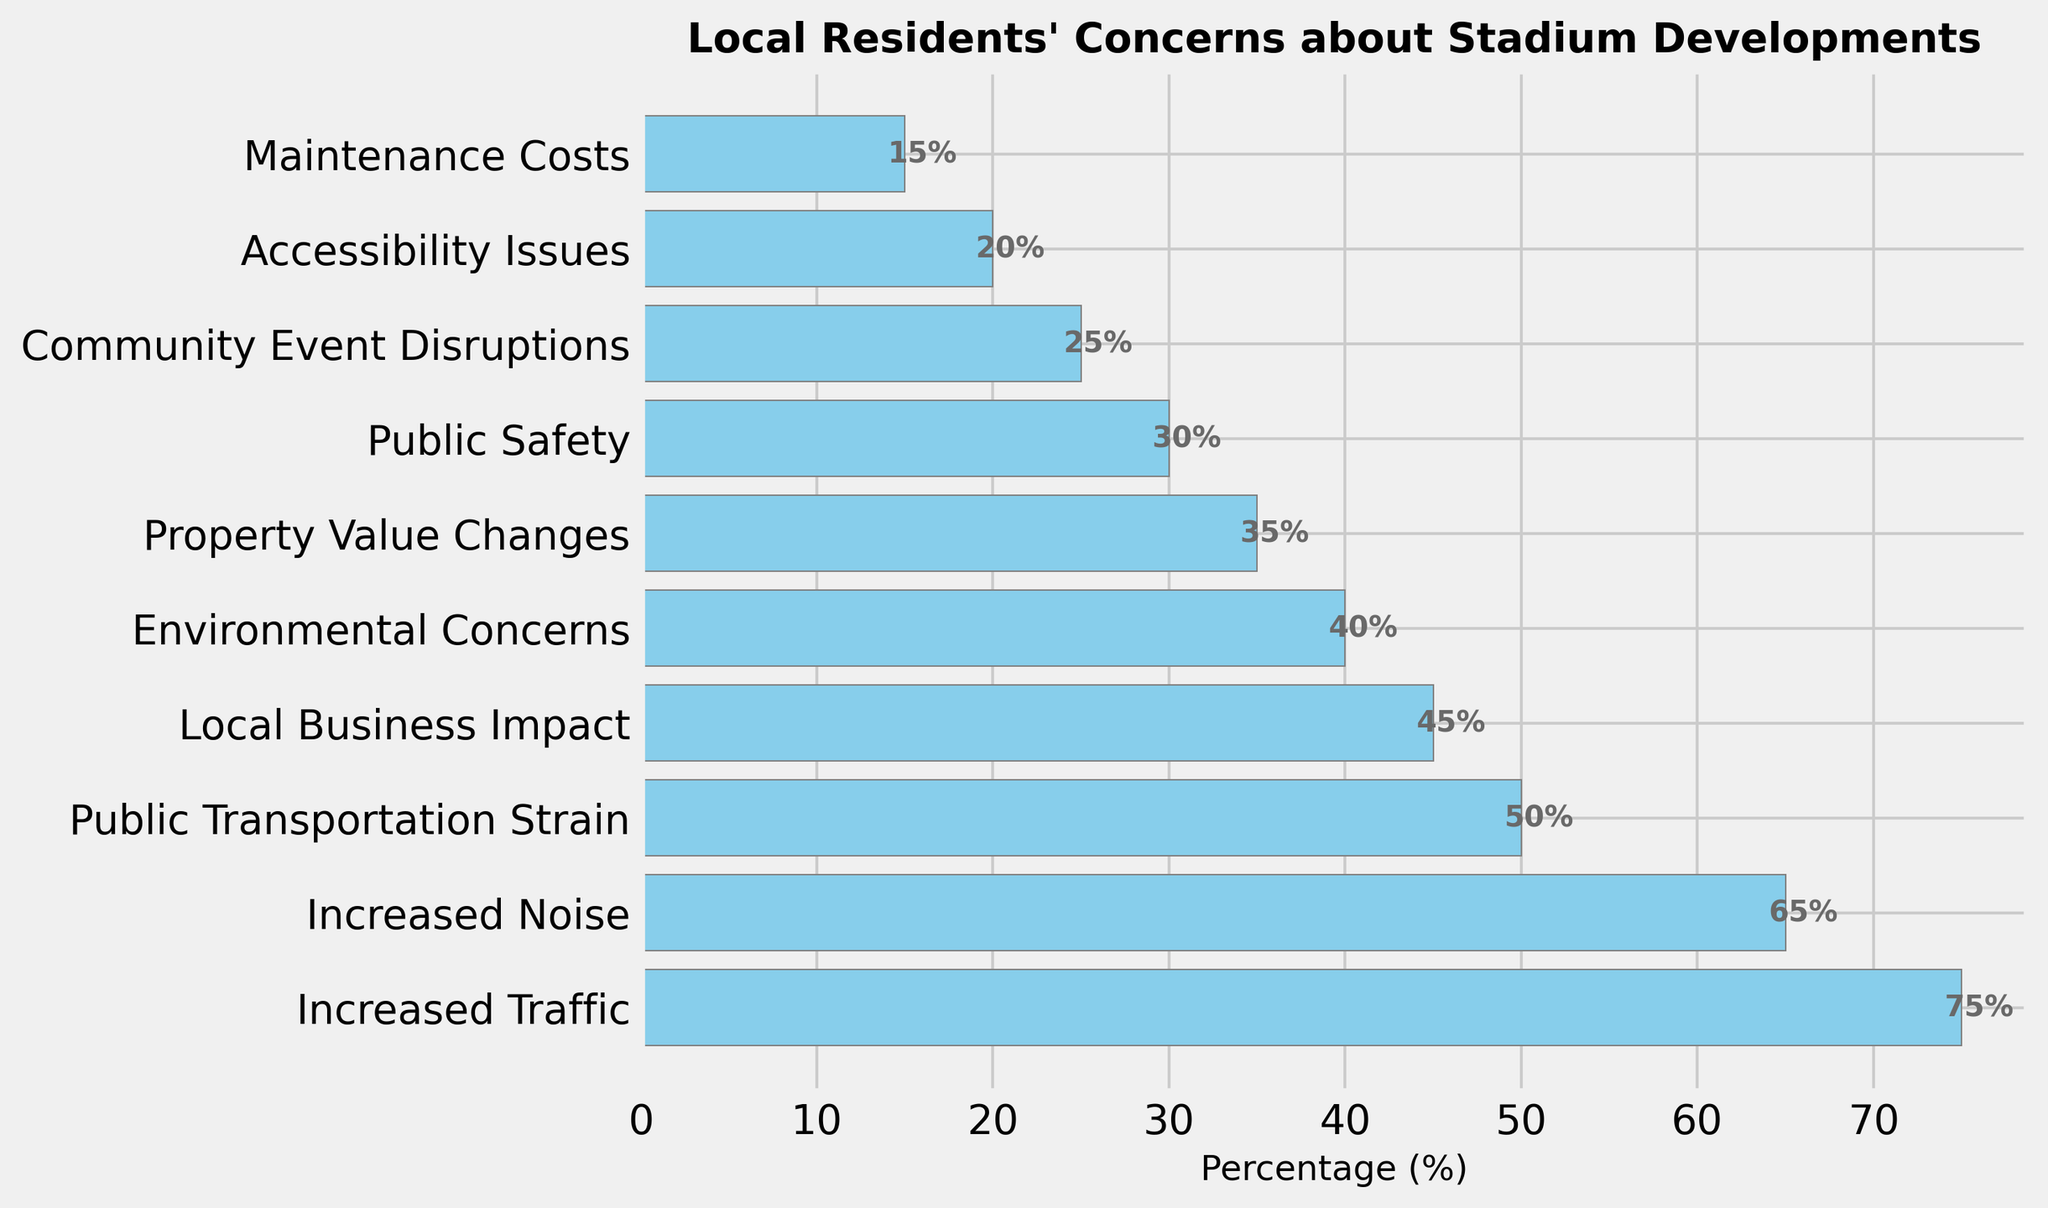What are the top two concerns of local residents regarding stadium developments? Select the bars with the highest values, which represent the top concerns. The top two bars are "Increased Traffic" at 75% and "Increased Noise" at 65%.
Answer: Increased Traffic and Increased Noise Which concern has a bigger percentage: Public Safety or Property Value Changes? Identify the bars for Public Safety and Property Value Changes and compare their lengths. Public Safety is at 30%, while Property Value Changes is at 35%.
Answer: Property Value Changes By how much does Increased Traffic exceed the combined concerns of Environmental Concerns and Community Event Disruptions? First, find the values of Environmental Concerns (40%) and Community Event Disruptions (25%), then sum them: 40% + 25% = 65%. Next, subtract this sum from the value of Increased Traffic (75%): 75% - 65% = 10%.
Answer: 10% Which concerns have percentages less than 30%? Identify all bars with percentages lower than 30%. These are Public Safety (30% is not less than), Community Event Disruptions (25%), Accessibility Issues (20%), and Maintenance Costs (15%).
Answer: Community Event Disruptions, Accessibility Issues, and Maintenance Costs What is the percentage difference between Increased Noise and Public Transportation Strain? Find the values for Increased Noise (65%) and Public Transportation Strain (50%). Calculate the difference: 65% - 50% = 15%.
Answer: 15% Which sections of the plot have the same color, and why? Observe the color used in the bars. All bars are colored skyblue. This consistent coloring is likely used to maintain visual uniformity and avoid distractions.
Answer: All bars are skyblue to maintain uniformity What is the total percentage of concerns related to Property Value Changes, Environmental Concerns, and Maintenance Costs? Sum the values of Property Value Changes (35%), Environmental Concerns (40%), and Maintenance Costs (15%): 35% + 40% + 15% = 90%.
Answer: 90% How does the concern for Local Business Impact compare to the concern for Accessibility Issues? Compare the bars for Local Business Impact and Accessibility Issues. Local Business Impact is at 45%, whereas Accessibility Issues is at 20%.
Answer: Local Business Impact is higher What concerns fall between 30% and 50%? Identify bars with values between 30% and 50%. These are Public Transportation Strain (50%), Local Business Impact (45%), Environmental Concerns (40%), and Property Value Changes (35%).
Answer: Public Transportation Strain, Local Business Impact, Environmental Concerns, and Property Value Changes 